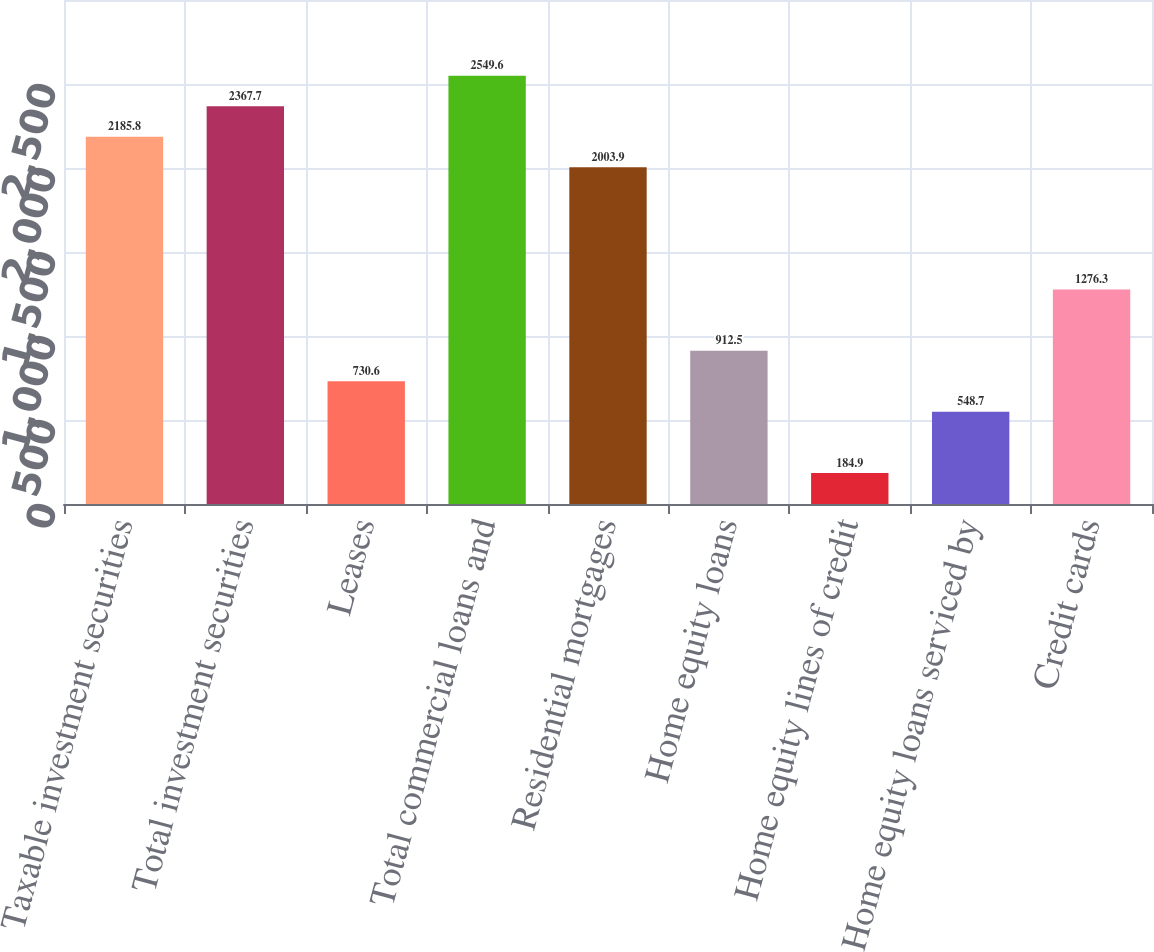<chart> <loc_0><loc_0><loc_500><loc_500><bar_chart><fcel>Taxable investment securities<fcel>Total investment securities<fcel>Leases<fcel>Total commercial loans and<fcel>Residential mortgages<fcel>Home equity loans<fcel>Home equity lines of credit<fcel>Home equity loans serviced by<fcel>Credit cards<nl><fcel>2185.8<fcel>2367.7<fcel>730.6<fcel>2549.6<fcel>2003.9<fcel>912.5<fcel>184.9<fcel>548.7<fcel>1276.3<nl></chart> 